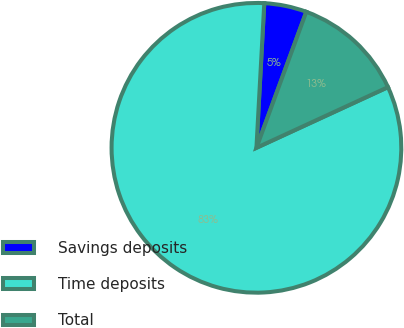Convert chart to OTSL. <chart><loc_0><loc_0><loc_500><loc_500><pie_chart><fcel>Savings deposits<fcel>Time deposits<fcel>Total<nl><fcel>4.73%<fcel>82.74%<fcel>12.53%<nl></chart> 